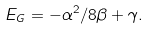Convert formula to latex. <formula><loc_0><loc_0><loc_500><loc_500>E _ { G } = - \alpha ^ { 2 } / 8 \beta + \gamma .</formula> 